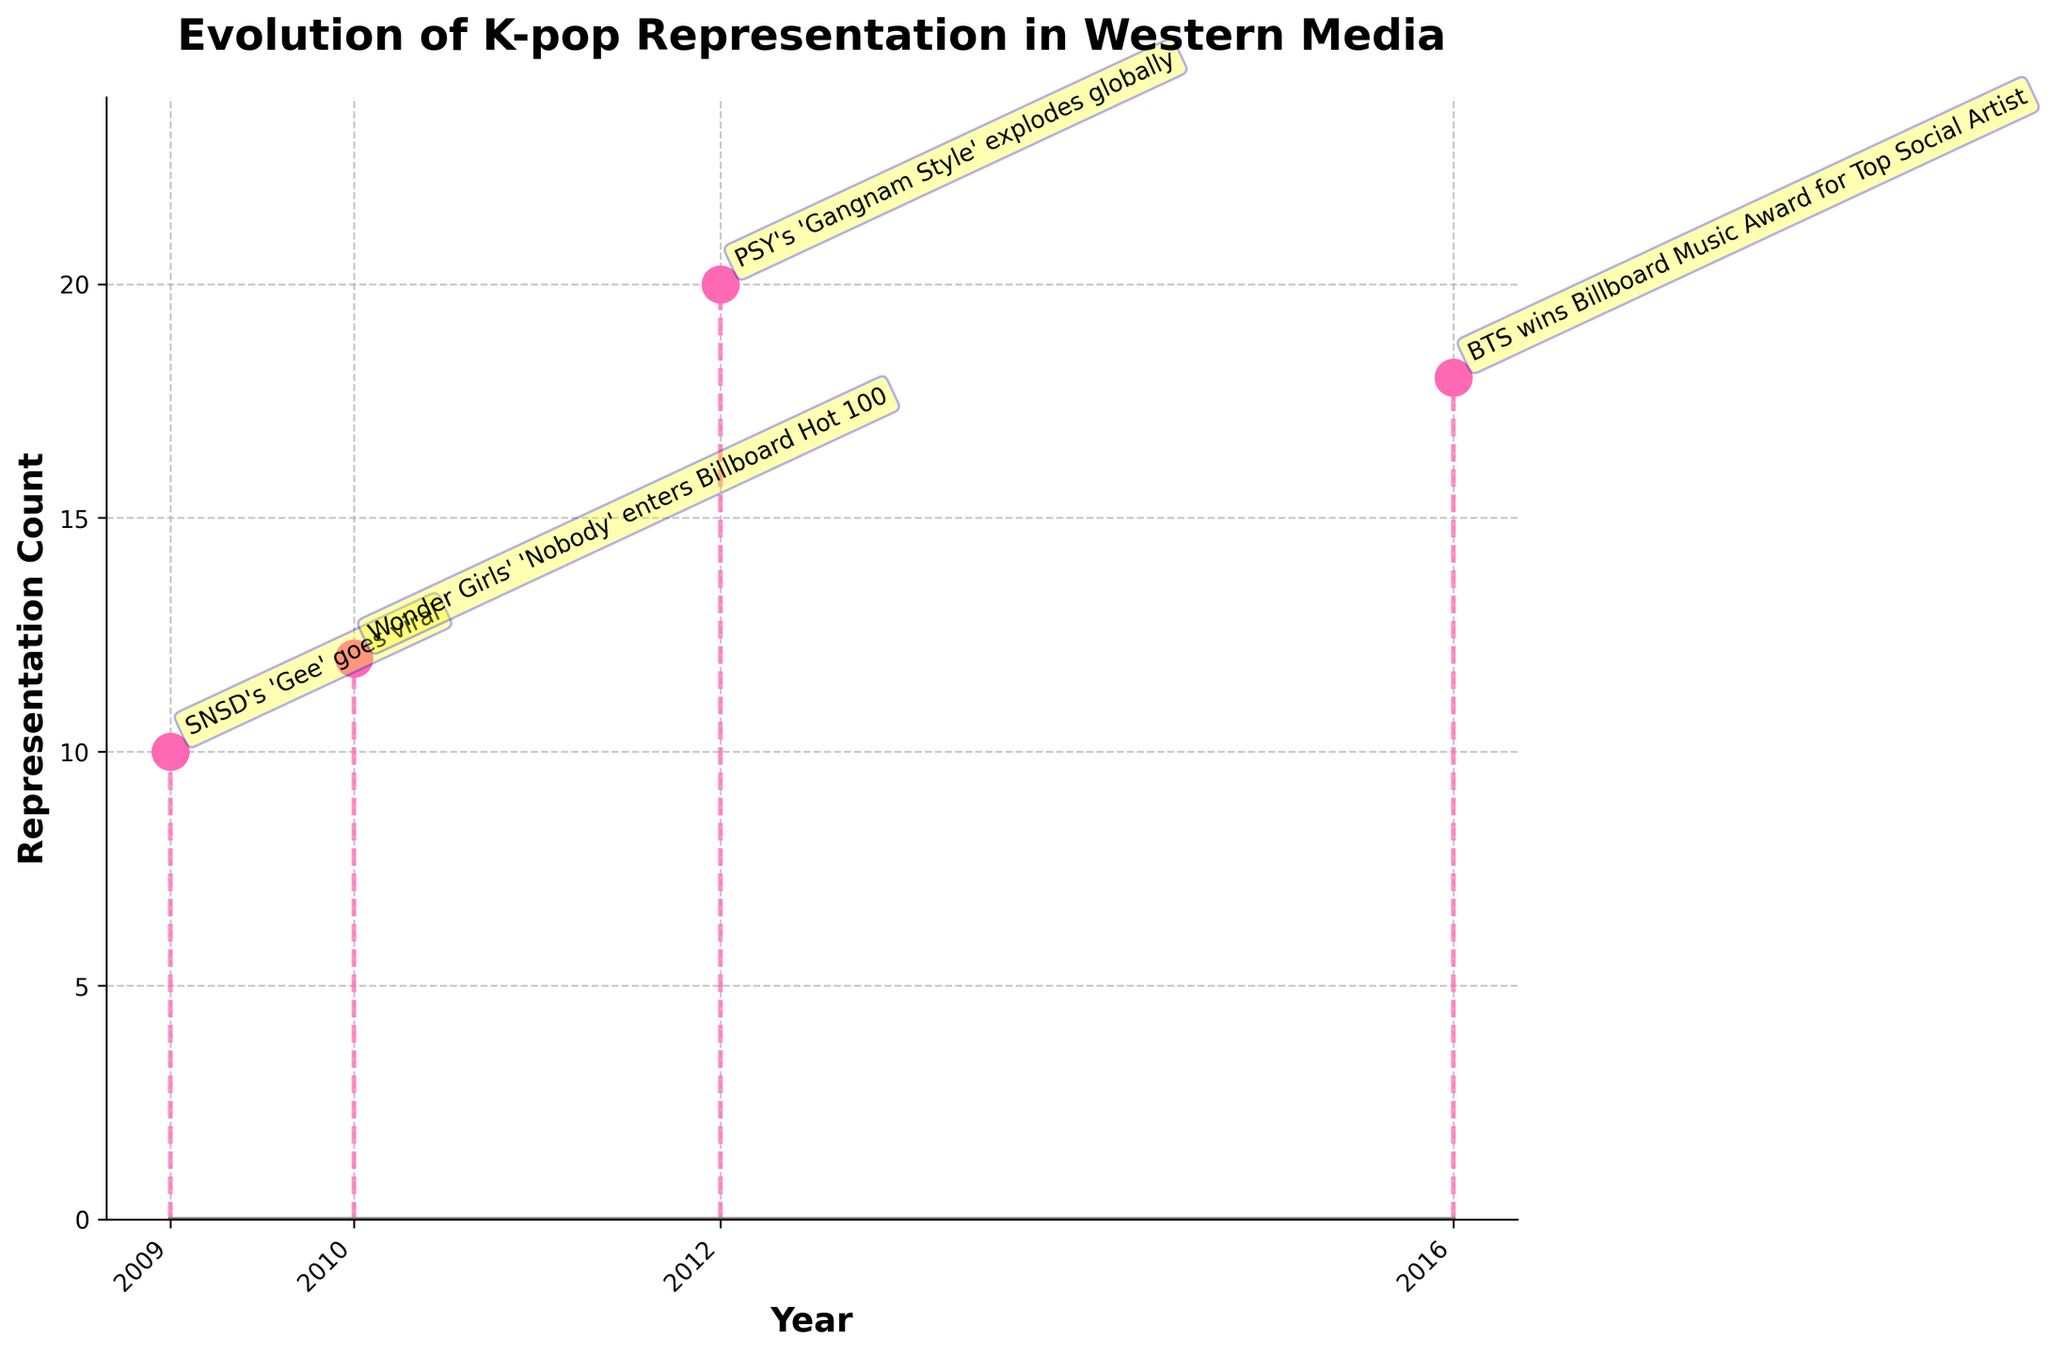what is the title of the stem plot? The title is displayed at the top of the figure in bold text. It gives an overview of the content of the plot.
Answer: Evolution of K-pop Representation in Western Media how many data points are represented in the figure? Each data point corresponds to a year on the x-axis and a count on the y-axis. Counting all points, we have four data points.
Answer: 4 which year had the highest representation count? By looking at the y-values, the year with the highest representation count corresponds to the tallest stem in the plot.
Answer: 2012 what was the representation count in 2016? Locate the year 2016 on the x-axis and then look at the corresponding y-value for the representation count.
Answer: 18 what event is associated with the year 2009? The annotation next to the 2009 stem indicates the significant event for that year.
Answer: SNSD's 'Gee' goes viral what is the difference in representation count between 2012 and 2010? Find the counts for both years from the y-axis and subtract the count for 2010 from the count for 2012. 20 - 12 = 8
Answer: 8 which event had the smallest associated representation count? Compare the annotations and the corresponding counts on the y-axis to identify the smallest.
Answer: SNSD's 'Gee' goes viral is there a year where the representation count decreased compared to the previous year? Compare the representation counts of each consecutive year. Notice the value dropped from 2012 to 2016.
Answer: Yes how does the count in 2016 compare to the count in 2009? Look at the y-values for 2016 and 2009 and compare the two values. 18 > 10
Answer: Higher what is the average representation count across all the years? Sum of all representation counts (10 + 12 + 20 + 18 = 60) divided by the number of years (4). 60/4
Answer: 15 